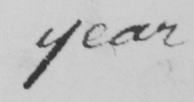Can you tell me what this handwritten text says? year 